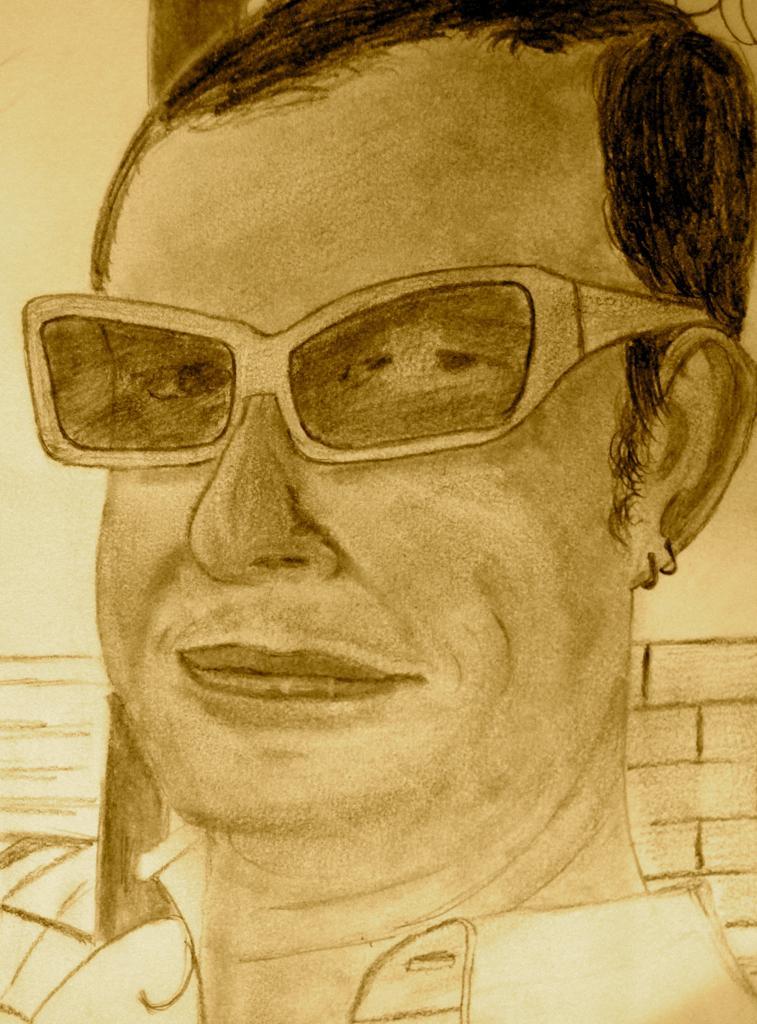Describe this image in one or two sentences. In this image, we can see a painting of a person. 